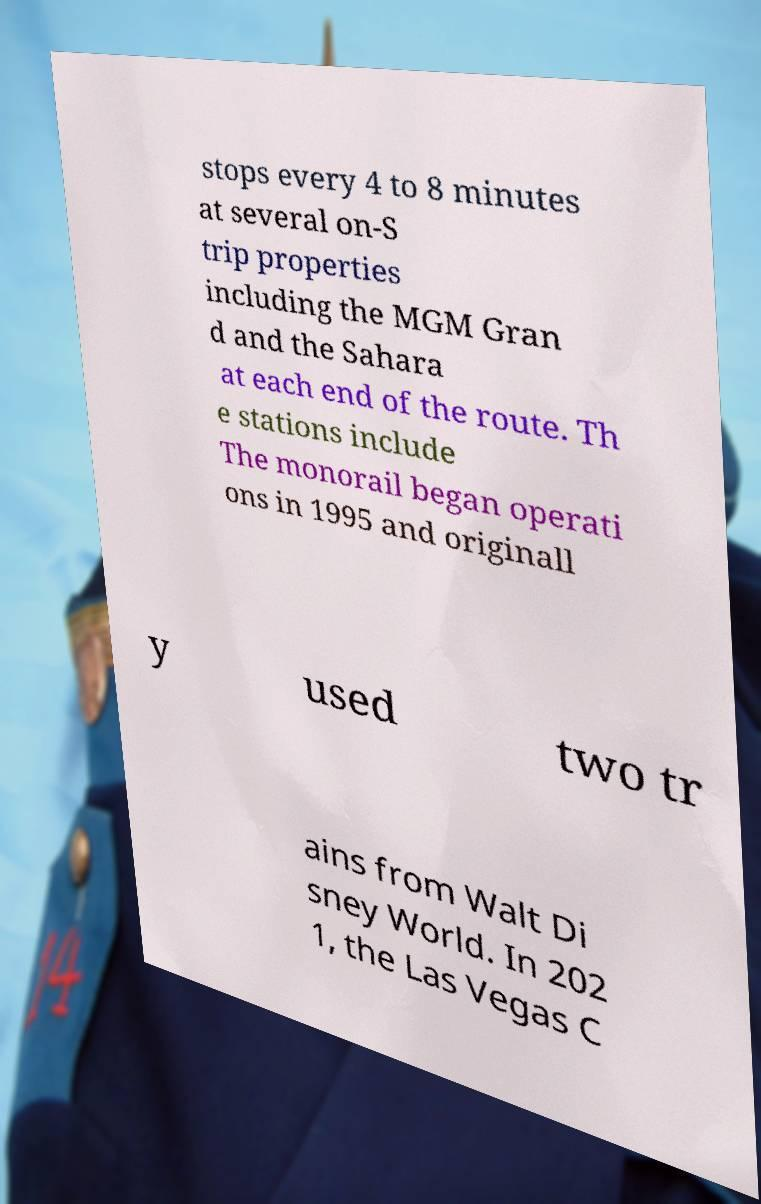There's text embedded in this image that I need extracted. Can you transcribe it verbatim? stops every 4 to 8 minutes at several on-S trip properties including the MGM Gran d and the Sahara at each end of the route. Th e stations include The monorail began operati ons in 1995 and originall y used two tr ains from Walt Di sney World. In 202 1, the Las Vegas C 